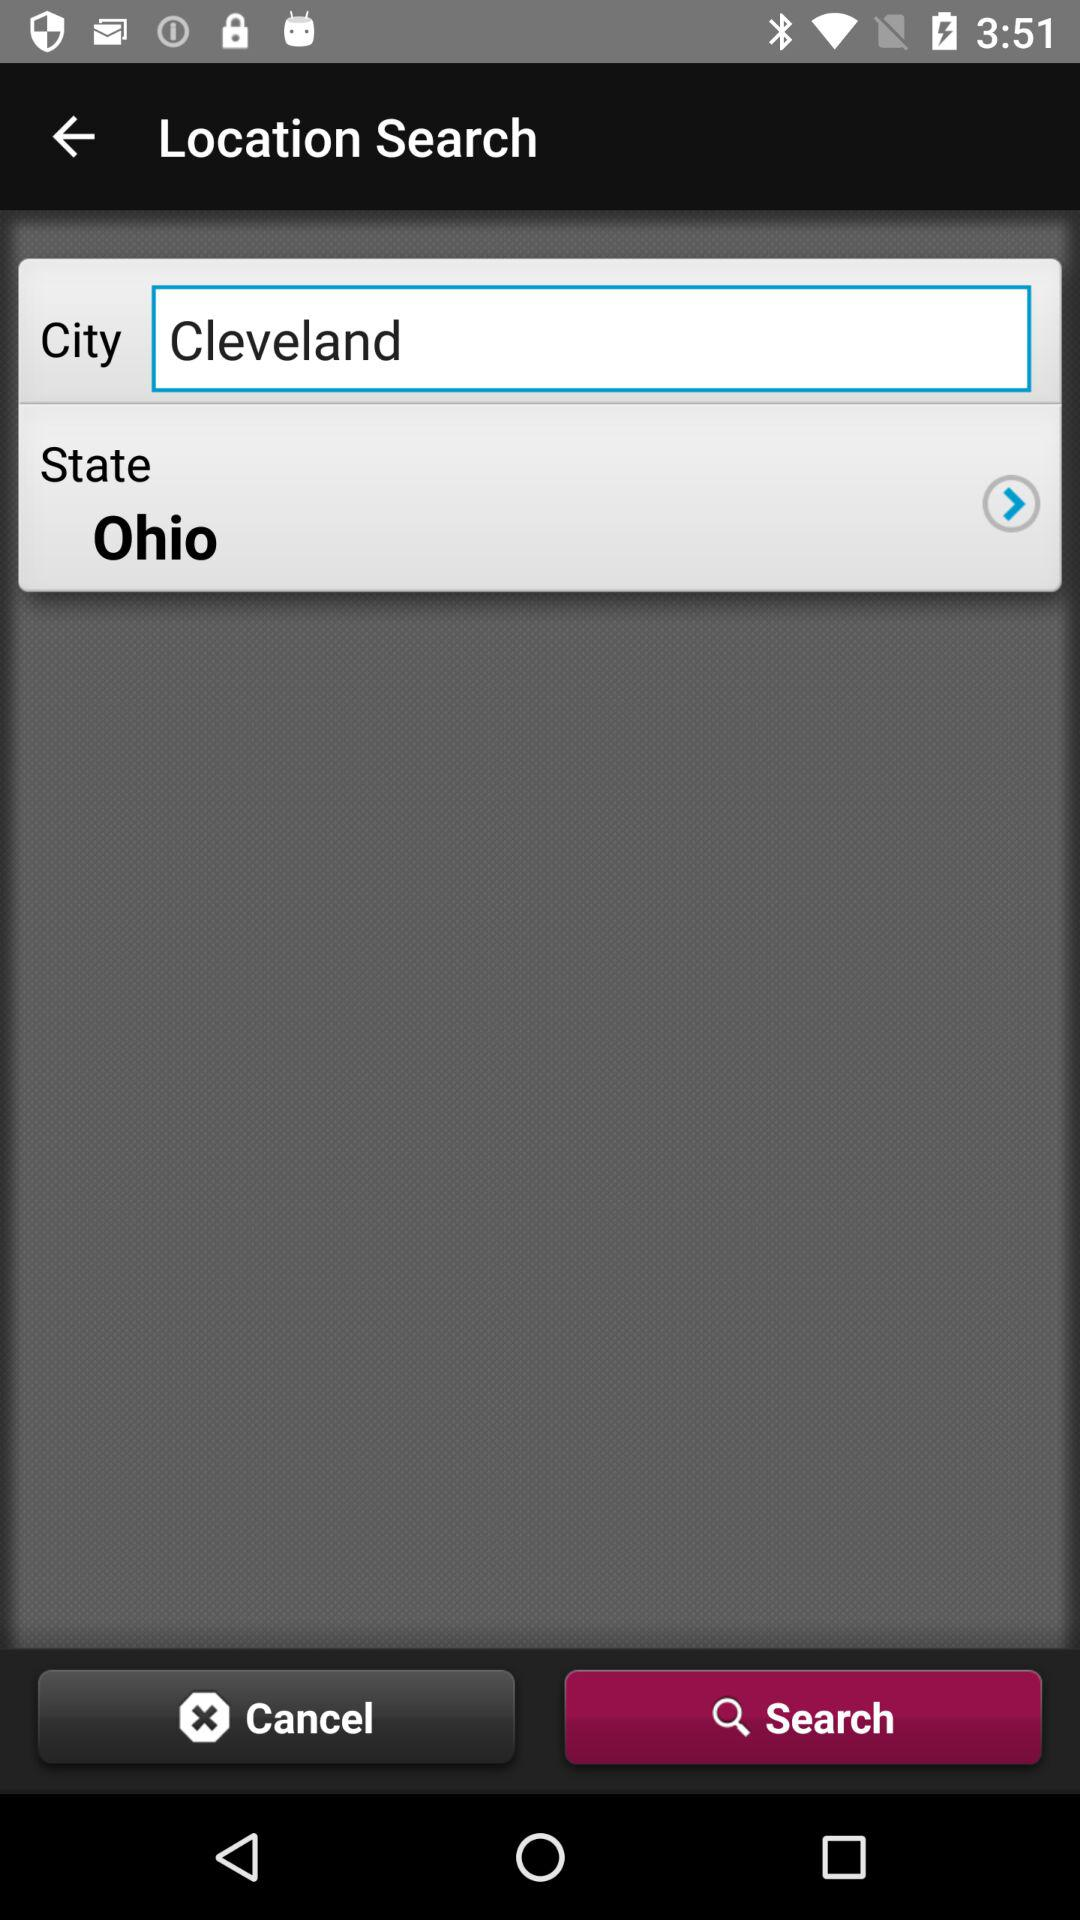What is the selected tab? The selected tab is "Search". 